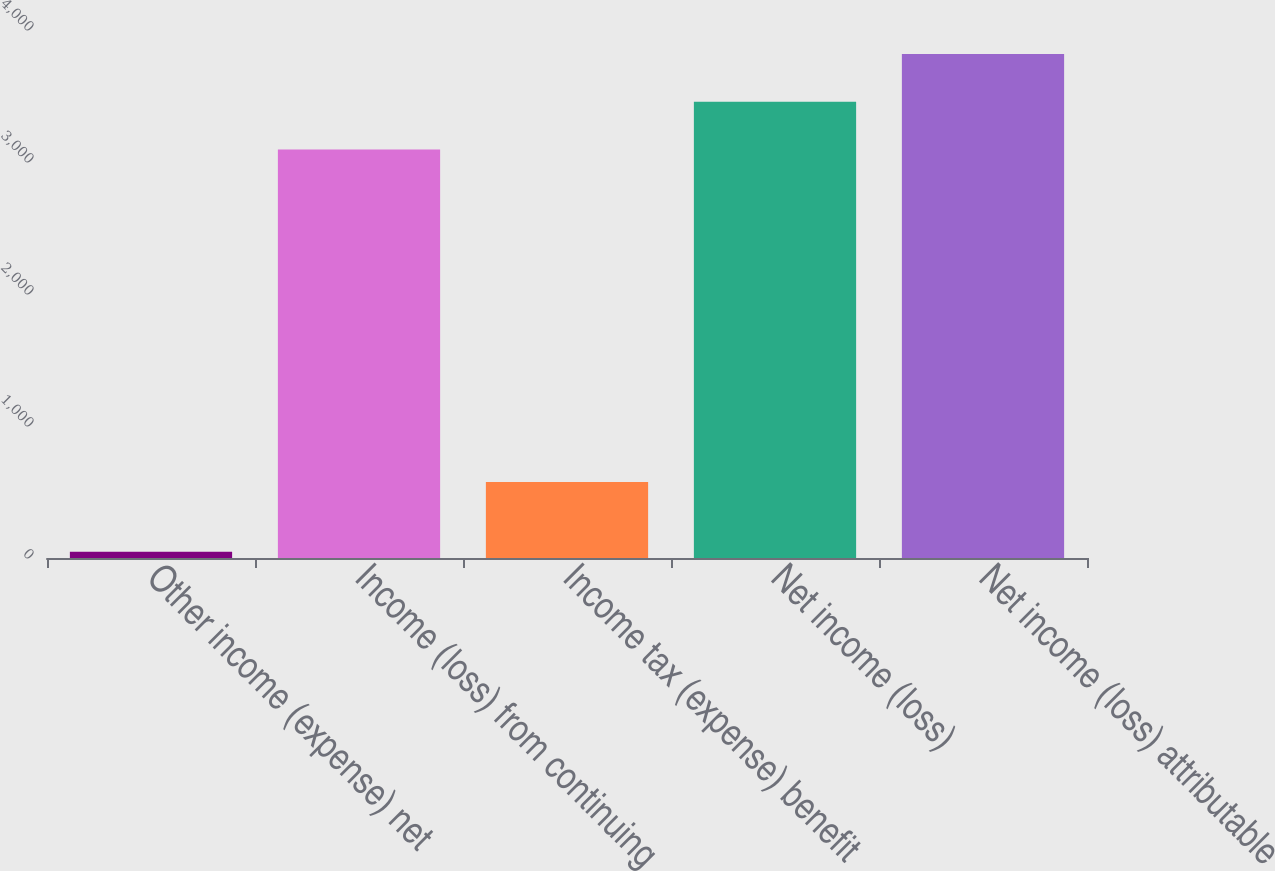Convert chart. <chart><loc_0><loc_0><loc_500><loc_500><bar_chart><fcel>Other income (expense) net<fcel>Income (loss) from continuing<fcel>Income tax (expense) benefit<fcel>Net income (loss)<fcel>Net income (loss) attributable<nl><fcel>48<fcel>3094<fcel>576<fcel>3456.2<fcel>3818.4<nl></chart> 